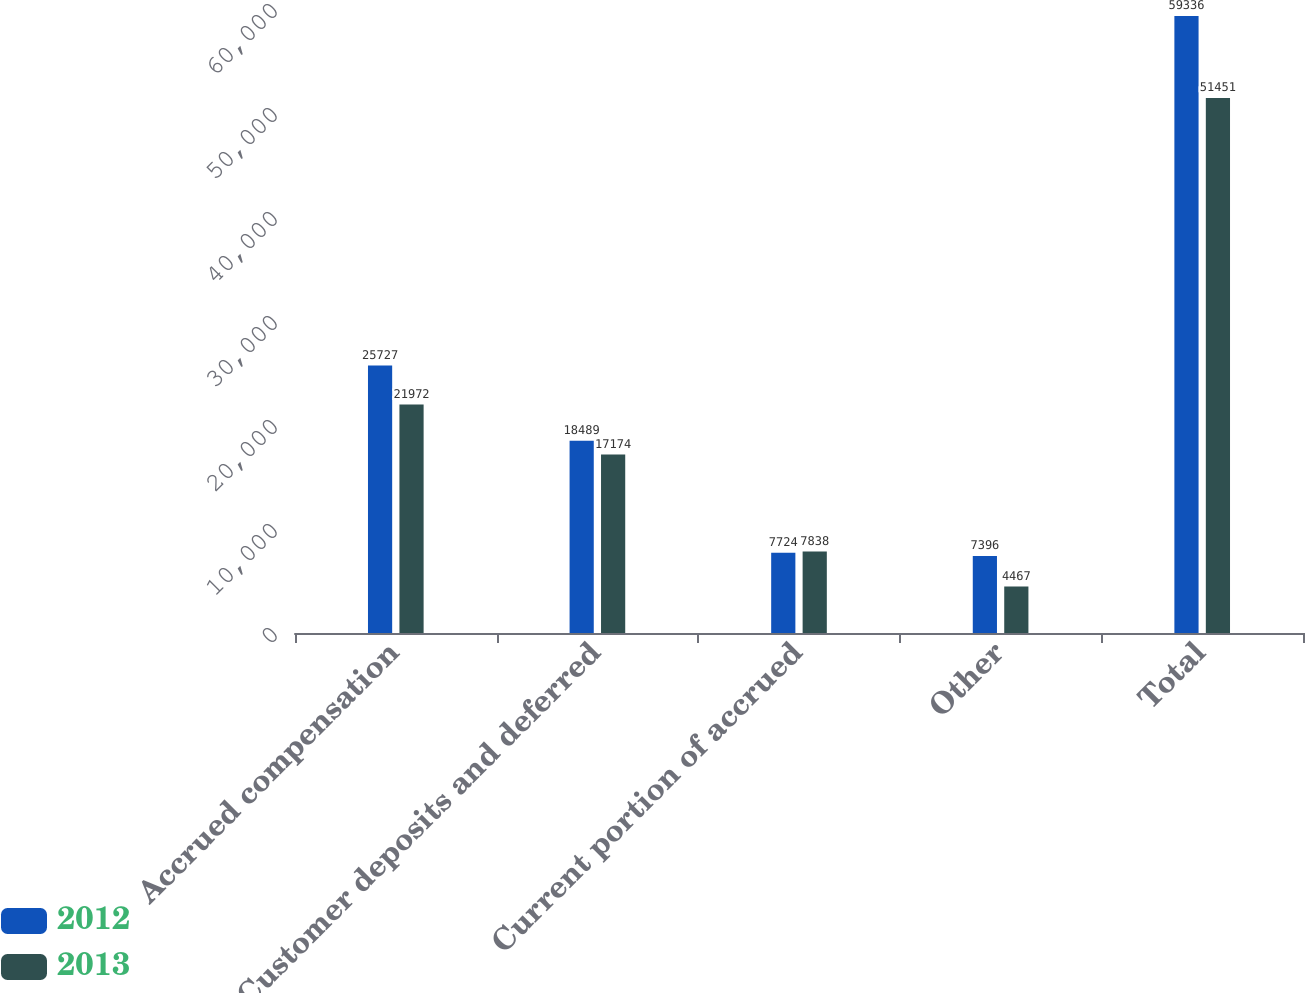Convert chart. <chart><loc_0><loc_0><loc_500><loc_500><stacked_bar_chart><ecel><fcel>Accrued compensation<fcel>Customer deposits and deferred<fcel>Current portion of accrued<fcel>Other<fcel>Total<nl><fcel>2012<fcel>25727<fcel>18489<fcel>7724<fcel>7396<fcel>59336<nl><fcel>2013<fcel>21972<fcel>17174<fcel>7838<fcel>4467<fcel>51451<nl></chart> 